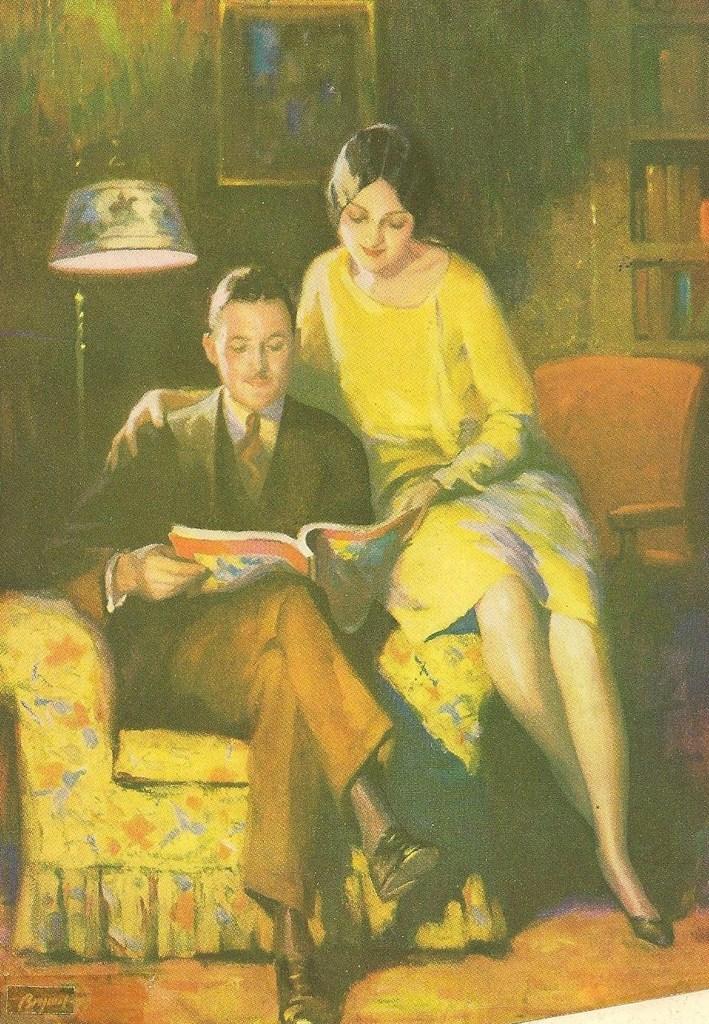Please provide a concise description of this image. In this picture we can see a man sitting on a chair holding a book and a woman beside him. We can also see a lamp, a group of books in the shelves and a frame on a wall. 